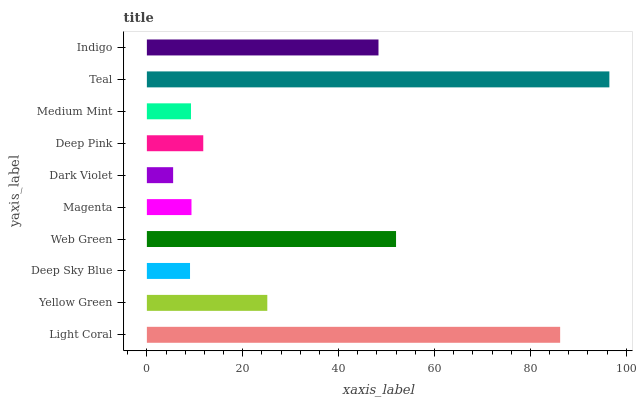Is Dark Violet the minimum?
Answer yes or no. Yes. Is Teal the maximum?
Answer yes or no. Yes. Is Yellow Green the minimum?
Answer yes or no. No. Is Yellow Green the maximum?
Answer yes or no. No. Is Light Coral greater than Yellow Green?
Answer yes or no. Yes. Is Yellow Green less than Light Coral?
Answer yes or no. Yes. Is Yellow Green greater than Light Coral?
Answer yes or no. No. Is Light Coral less than Yellow Green?
Answer yes or no. No. Is Yellow Green the high median?
Answer yes or no. Yes. Is Deep Pink the low median?
Answer yes or no. Yes. Is Deep Sky Blue the high median?
Answer yes or no. No. Is Yellow Green the low median?
Answer yes or no. No. 